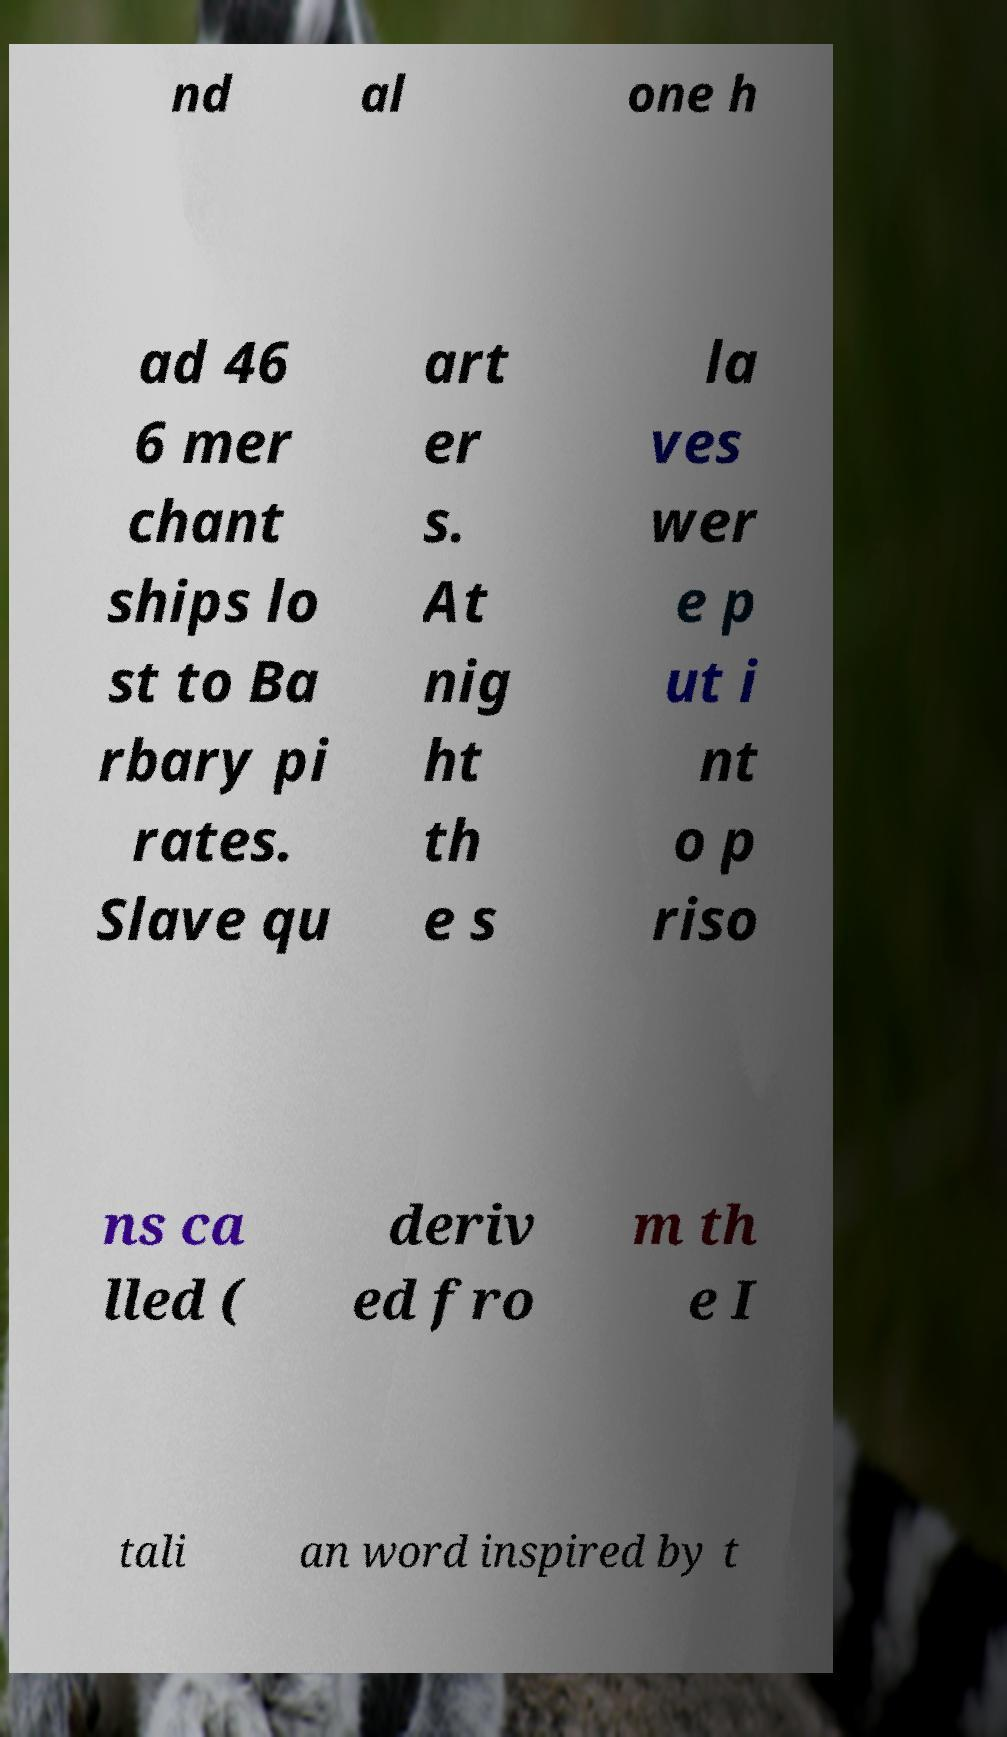Can you accurately transcribe the text from the provided image for me? nd al one h ad 46 6 mer chant ships lo st to Ba rbary pi rates. Slave qu art er s. At nig ht th e s la ves wer e p ut i nt o p riso ns ca lled ( deriv ed fro m th e I tali an word inspired by t 